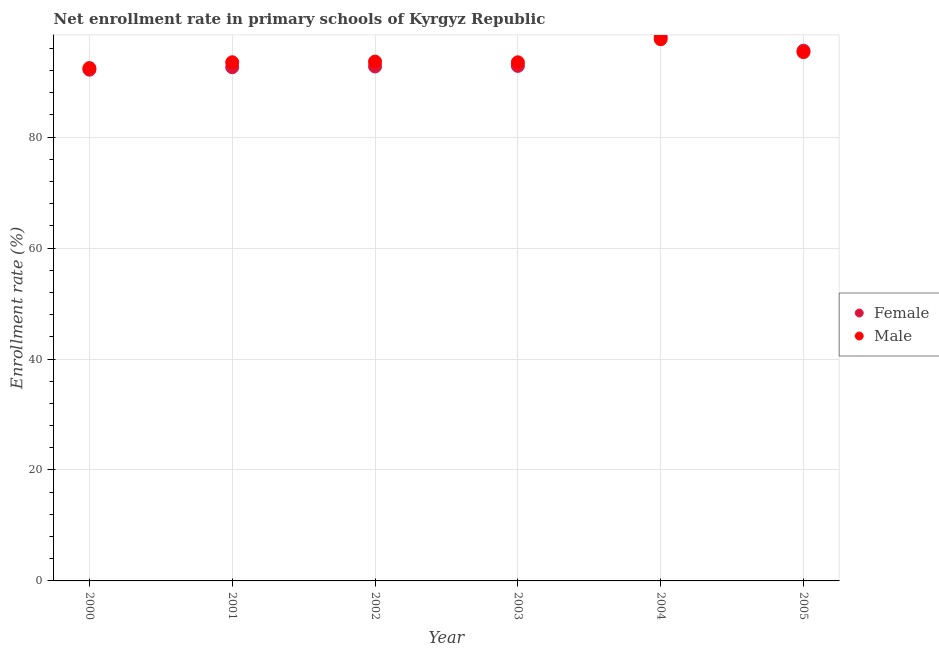How many different coloured dotlines are there?
Offer a very short reply. 2. Is the number of dotlines equal to the number of legend labels?
Provide a short and direct response. Yes. What is the enrollment rate of female students in 2001?
Provide a succinct answer. 92.61. Across all years, what is the maximum enrollment rate of male students?
Offer a very short reply. 97.65. Across all years, what is the minimum enrollment rate of female students?
Offer a very short reply. 92.16. What is the total enrollment rate of female students in the graph?
Your answer should be compact. 564.07. What is the difference between the enrollment rate of male students in 2004 and that in 2005?
Your response must be concise. 2.32. What is the difference between the enrollment rate of male students in 2003 and the enrollment rate of female students in 2002?
Provide a short and direct response. 0.75. What is the average enrollment rate of female students per year?
Make the answer very short. 94.01. In the year 2005, what is the difference between the enrollment rate of female students and enrollment rate of male students?
Ensure brevity in your answer.  0.25. What is the ratio of the enrollment rate of male students in 2001 to that in 2004?
Make the answer very short. 0.96. Is the enrollment rate of female students in 2002 less than that in 2003?
Ensure brevity in your answer.  Yes. What is the difference between the highest and the second highest enrollment rate of male students?
Provide a short and direct response. 2.32. What is the difference between the highest and the lowest enrollment rate of male students?
Make the answer very short. 5.2. In how many years, is the enrollment rate of male students greater than the average enrollment rate of male students taken over all years?
Provide a short and direct response. 2. Is the sum of the enrollment rate of male students in 2003 and 2004 greater than the maximum enrollment rate of female students across all years?
Offer a terse response. Yes. Does the enrollment rate of male students monotonically increase over the years?
Your response must be concise. No. Is the enrollment rate of male students strictly greater than the enrollment rate of female students over the years?
Offer a very short reply. No. How many years are there in the graph?
Offer a very short reply. 6. What is the difference between two consecutive major ticks on the Y-axis?
Give a very brief answer. 20. Are the values on the major ticks of Y-axis written in scientific E-notation?
Give a very brief answer. No. Does the graph contain grids?
Make the answer very short. Yes. What is the title of the graph?
Keep it short and to the point. Net enrollment rate in primary schools of Kyrgyz Republic. Does "% of GNI" appear as one of the legend labels in the graph?
Provide a succinct answer. No. What is the label or title of the X-axis?
Your response must be concise. Year. What is the label or title of the Y-axis?
Provide a short and direct response. Enrollment rate (%). What is the Enrollment rate (%) in Female in 2000?
Ensure brevity in your answer.  92.16. What is the Enrollment rate (%) of Male in 2000?
Your answer should be compact. 92.45. What is the Enrollment rate (%) of Female in 2001?
Provide a succinct answer. 92.61. What is the Enrollment rate (%) in Male in 2001?
Offer a very short reply. 93.5. What is the Enrollment rate (%) of Female in 2002?
Offer a terse response. 92.74. What is the Enrollment rate (%) in Male in 2002?
Your answer should be compact. 93.61. What is the Enrollment rate (%) of Female in 2003?
Provide a succinct answer. 92.84. What is the Enrollment rate (%) in Male in 2003?
Your response must be concise. 93.49. What is the Enrollment rate (%) in Female in 2004?
Ensure brevity in your answer.  98.14. What is the Enrollment rate (%) in Male in 2004?
Your response must be concise. 97.65. What is the Enrollment rate (%) of Female in 2005?
Your answer should be compact. 95.58. What is the Enrollment rate (%) of Male in 2005?
Ensure brevity in your answer.  95.33. Across all years, what is the maximum Enrollment rate (%) of Female?
Provide a short and direct response. 98.14. Across all years, what is the maximum Enrollment rate (%) in Male?
Your answer should be very brief. 97.65. Across all years, what is the minimum Enrollment rate (%) of Female?
Your answer should be compact. 92.16. Across all years, what is the minimum Enrollment rate (%) in Male?
Your answer should be compact. 92.45. What is the total Enrollment rate (%) in Female in the graph?
Provide a succinct answer. 564.07. What is the total Enrollment rate (%) in Male in the graph?
Give a very brief answer. 566.03. What is the difference between the Enrollment rate (%) of Female in 2000 and that in 2001?
Your answer should be compact. -0.44. What is the difference between the Enrollment rate (%) in Male in 2000 and that in 2001?
Offer a terse response. -1.05. What is the difference between the Enrollment rate (%) of Female in 2000 and that in 2002?
Provide a succinct answer. -0.58. What is the difference between the Enrollment rate (%) of Male in 2000 and that in 2002?
Ensure brevity in your answer.  -1.16. What is the difference between the Enrollment rate (%) in Female in 2000 and that in 2003?
Your answer should be compact. -0.68. What is the difference between the Enrollment rate (%) in Male in 2000 and that in 2003?
Provide a short and direct response. -1.04. What is the difference between the Enrollment rate (%) in Female in 2000 and that in 2004?
Your answer should be very brief. -5.98. What is the difference between the Enrollment rate (%) in Male in 2000 and that in 2004?
Ensure brevity in your answer.  -5.2. What is the difference between the Enrollment rate (%) of Female in 2000 and that in 2005?
Provide a short and direct response. -3.42. What is the difference between the Enrollment rate (%) in Male in 2000 and that in 2005?
Ensure brevity in your answer.  -2.88. What is the difference between the Enrollment rate (%) of Female in 2001 and that in 2002?
Provide a short and direct response. -0.14. What is the difference between the Enrollment rate (%) of Male in 2001 and that in 2002?
Your answer should be compact. -0.12. What is the difference between the Enrollment rate (%) of Female in 2001 and that in 2003?
Offer a terse response. -0.24. What is the difference between the Enrollment rate (%) in Male in 2001 and that in 2003?
Offer a terse response. 0.01. What is the difference between the Enrollment rate (%) in Female in 2001 and that in 2004?
Your response must be concise. -5.53. What is the difference between the Enrollment rate (%) in Male in 2001 and that in 2004?
Provide a succinct answer. -4.15. What is the difference between the Enrollment rate (%) in Female in 2001 and that in 2005?
Offer a very short reply. -2.97. What is the difference between the Enrollment rate (%) in Male in 2001 and that in 2005?
Your answer should be very brief. -1.83. What is the difference between the Enrollment rate (%) in Female in 2002 and that in 2003?
Offer a terse response. -0.1. What is the difference between the Enrollment rate (%) in Male in 2002 and that in 2003?
Ensure brevity in your answer.  0.12. What is the difference between the Enrollment rate (%) in Female in 2002 and that in 2004?
Ensure brevity in your answer.  -5.39. What is the difference between the Enrollment rate (%) of Male in 2002 and that in 2004?
Offer a terse response. -4.04. What is the difference between the Enrollment rate (%) in Female in 2002 and that in 2005?
Your response must be concise. -2.84. What is the difference between the Enrollment rate (%) in Male in 2002 and that in 2005?
Offer a terse response. -1.71. What is the difference between the Enrollment rate (%) of Female in 2003 and that in 2004?
Provide a short and direct response. -5.29. What is the difference between the Enrollment rate (%) of Male in 2003 and that in 2004?
Your answer should be compact. -4.16. What is the difference between the Enrollment rate (%) of Female in 2003 and that in 2005?
Provide a short and direct response. -2.74. What is the difference between the Enrollment rate (%) in Male in 2003 and that in 2005?
Provide a succinct answer. -1.84. What is the difference between the Enrollment rate (%) of Female in 2004 and that in 2005?
Ensure brevity in your answer.  2.56. What is the difference between the Enrollment rate (%) in Male in 2004 and that in 2005?
Give a very brief answer. 2.32. What is the difference between the Enrollment rate (%) of Female in 2000 and the Enrollment rate (%) of Male in 2001?
Your response must be concise. -1.34. What is the difference between the Enrollment rate (%) of Female in 2000 and the Enrollment rate (%) of Male in 2002?
Provide a succinct answer. -1.45. What is the difference between the Enrollment rate (%) in Female in 2000 and the Enrollment rate (%) in Male in 2003?
Give a very brief answer. -1.33. What is the difference between the Enrollment rate (%) of Female in 2000 and the Enrollment rate (%) of Male in 2004?
Provide a succinct answer. -5.49. What is the difference between the Enrollment rate (%) in Female in 2000 and the Enrollment rate (%) in Male in 2005?
Keep it short and to the point. -3.17. What is the difference between the Enrollment rate (%) in Female in 2001 and the Enrollment rate (%) in Male in 2002?
Your answer should be compact. -1.01. What is the difference between the Enrollment rate (%) of Female in 2001 and the Enrollment rate (%) of Male in 2003?
Ensure brevity in your answer.  -0.88. What is the difference between the Enrollment rate (%) of Female in 2001 and the Enrollment rate (%) of Male in 2004?
Give a very brief answer. -5.05. What is the difference between the Enrollment rate (%) of Female in 2001 and the Enrollment rate (%) of Male in 2005?
Offer a very short reply. -2.72. What is the difference between the Enrollment rate (%) of Female in 2002 and the Enrollment rate (%) of Male in 2003?
Offer a terse response. -0.75. What is the difference between the Enrollment rate (%) in Female in 2002 and the Enrollment rate (%) in Male in 2004?
Give a very brief answer. -4.91. What is the difference between the Enrollment rate (%) of Female in 2002 and the Enrollment rate (%) of Male in 2005?
Give a very brief answer. -2.58. What is the difference between the Enrollment rate (%) of Female in 2003 and the Enrollment rate (%) of Male in 2004?
Offer a very short reply. -4.81. What is the difference between the Enrollment rate (%) in Female in 2003 and the Enrollment rate (%) in Male in 2005?
Ensure brevity in your answer.  -2.48. What is the difference between the Enrollment rate (%) of Female in 2004 and the Enrollment rate (%) of Male in 2005?
Offer a terse response. 2.81. What is the average Enrollment rate (%) of Female per year?
Provide a succinct answer. 94.01. What is the average Enrollment rate (%) in Male per year?
Provide a succinct answer. 94.34. In the year 2000, what is the difference between the Enrollment rate (%) in Female and Enrollment rate (%) in Male?
Your answer should be compact. -0.29. In the year 2001, what is the difference between the Enrollment rate (%) of Female and Enrollment rate (%) of Male?
Provide a succinct answer. -0.89. In the year 2002, what is the difference between the Enrollment rate (%) in Female and Enrollment rate (%) in Male?
Provide a short and direct response. -0.87. In the year 2003, what is the difference between the Enrollment rate (%) in Female and Enrollment rate (%) in Male?
Provide a short and direct response. -0.65. In the year 2004, what is the difference between the Enrollment rate (%) in Female and Enrollment rate (%) in Male?
Provide a succinct answer. 0.48. In the year 2005, what is the difference between the Enrollment rate (%) of Female and Enrollment rate (%) of Male?
Provide a short and direct response. 0.25. What is the ratio of the Enrollment rate (%) of Female in 2000 to that in 2002?
Your response must be concise. 0.99. What is the ratio of the Enrollment rate (%) of Male in 2000 to that in 2002?
Provide a succinct answer. 0.99. What is the ratio of the Enrollment rate (%) in Male in 2000 to that in 2003?
Make the answer very short. 0.99. What is the ratio of the Enrollment rate (%) in Female in 2000 to that in 2004?
Ensure brevity in your answer.  0.94. What is the ratio of the Enrollment rate (%) of Male in 2000 to that in 2004?
Make the answer very short. 0.95. What is the ratio of the Enrollment rate (%) in Female in 2000 to that in 2005?
Your answer should be compact. 0.96. What is the ratio of the Enrollment rate (%) in Male in 2000 to that in 2005?
Make the answer very short. 0.97. What is the ratio of the Enrollment rate (%) in Female in 2001 to that in 2004?
Provide a short and direct response. 0.94. What is the ratio of the Enrollment rate (%) of Male in 2001 to that in 2004?
Keep it short and to the point. 0.96. What is the ratio of the Enrollment rate (%) of Female in 2001 to that in 2005?
Keep it short and to the point. 0.97. What is the ratio of the Enrollment rate (%) in Male in 2001 to that in 2005?
Your answer should be very brief. 0.98. What is the ratio of the Enrollment rate (%) of Female in 2002 to that in 2003?
Your answer should be compact. 1. What is the ratio of the Enrollment rate (%) of Male in 2002 to that in 2003?
Provide a succinct answer. 1. What is the ratio of the Enrollment rate (%) of Female in 2002 to that in 2004?
Your answer should be very brief. 0.94. What is the ratio of the Enrollment rate (%) of Male in 2002 to that in 2004?
Give a very brief answer. 0.96. What is the ratio of the Enrollment rate (%) in Female in 2002 to that in 2005?
Offer a very short reply. 0.97. What is the ratio of the Enrollment rate (%) of Female in 2003 to that in 2004?
Offer a terse response. 0.95. What is the ratio of the Enrollment rate (%) in Male in 2003 to that in 2004?
Offer a terse response. 0.96. What is the ratio of the Enrollment rate (%) in Female in 2003 to that in 2005?
Keep it short and to the point. 0.97. What is the ratio of the Enrollment rate (%) in Male in 2003 to that in 2005?
Provide a short and direct response. 0.98. What is the ratio of the Enrollment rate (%) of Female in 2004 to that in 2005?
Offer a very short reply. 1.03. What is the ratio of the Enrollment rate (%) of Male in 2004 to that in 2005?
Your answer should be compact. 1.02. What is the difference between the highest and the second highest Enrollment rate (%) of Female?
Provide a short and direct response. 2.56. What is the difference between the highest and the second highest Enrollment rate (%) in Male?
Give a very brief answer. 2.32. What is the difference between the highest and the lowest Enrollment rate (%) in Female?
Provide a succinct answer. 5.98. What is the difference between the highest and the lowest Enrollment rate (%) of Male?
Provide a short and direct response. 5.2. 